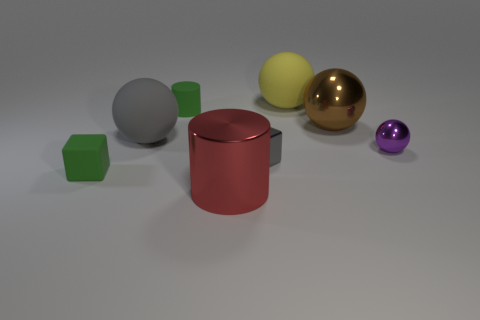Can you describe the texture of the gray sphere? The surface of the gray sphere looks smooth with a matte finish, suggesting it could be made of a non-reflective material, such as clay or stone. 